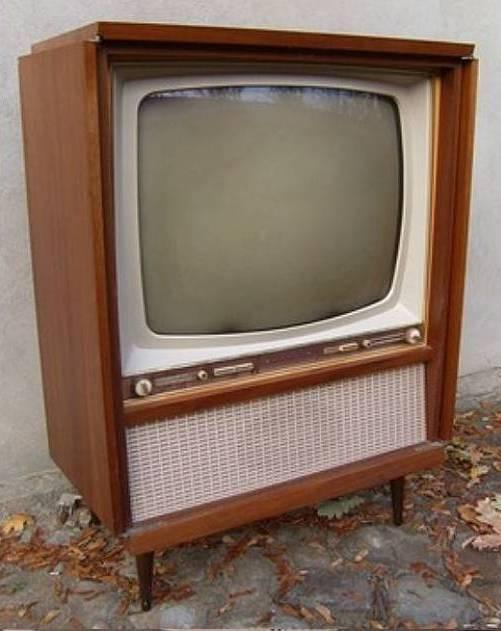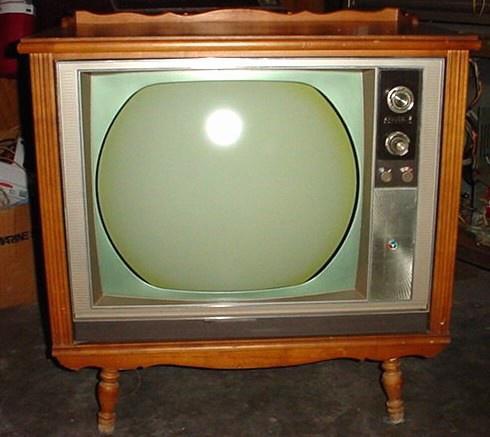The first image is the image on the left, the second image is the image on the right. Given the left and right images, does the statement "One of the TV sets does not have legs under it." hold true? Answer yes or no. No. 